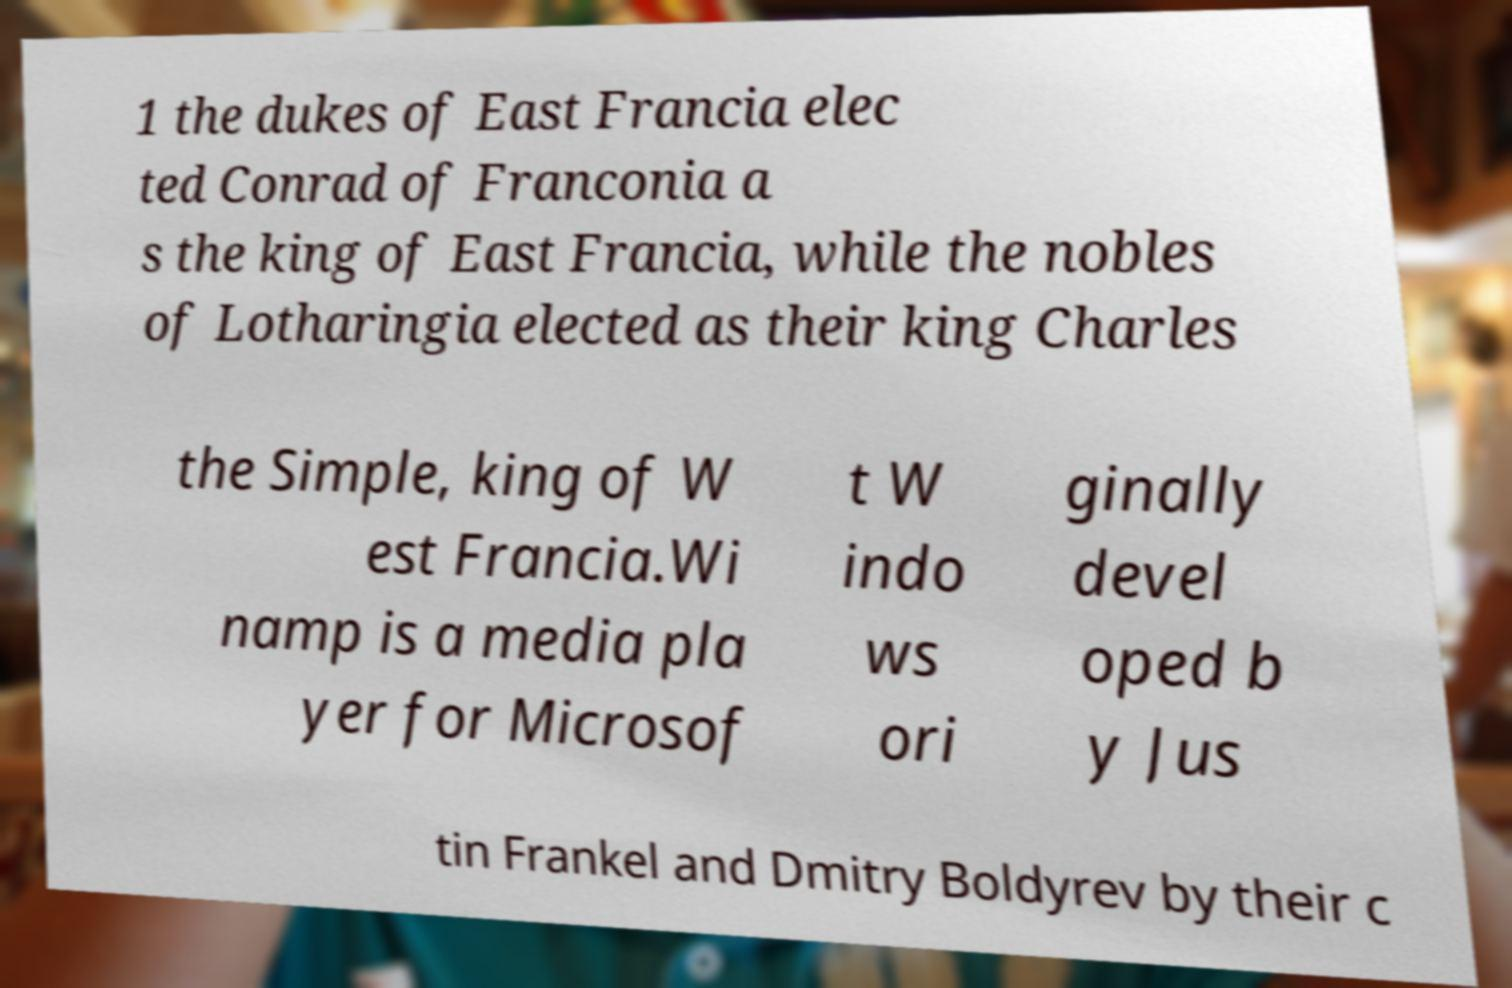Could you extract and type out the text from this image? 1 the dukes of East Francia elec ted Conrad of Franconia a s the king of East Francia, while the nobles of Lotharingia elected as their king Charles the Simple, king of W est Francia.Wi namp is a media pla yer for Microsof t W indo ws ori ginally devel oped b y Jus tin Frankel and Dmitry Boldyrev by their c 